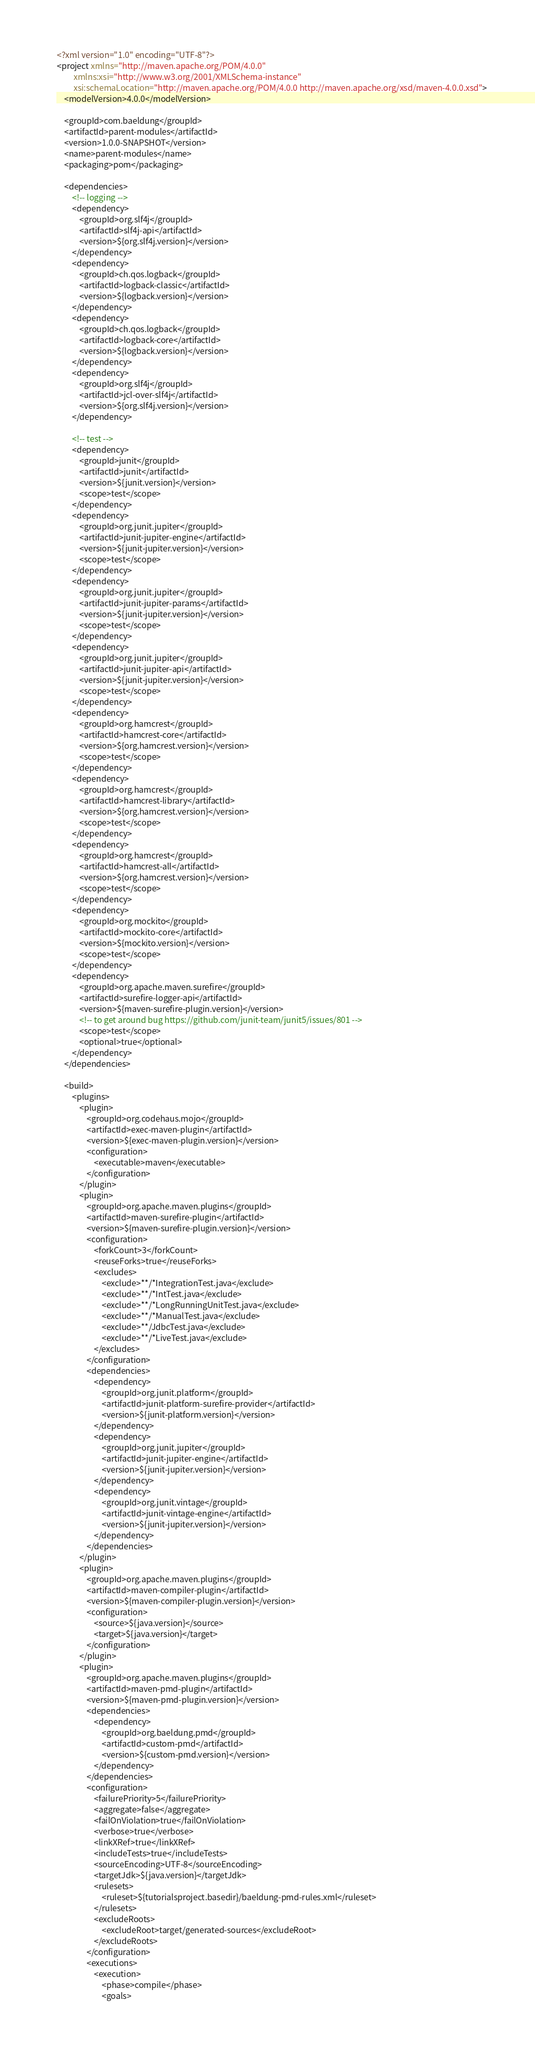Convert code to text. <code><loc_0><loc_0><loc_500><loc_500><_XML_><?xml version="1.0" encoding="UTF-8"?>
<project xmlns="http://maven.apache.org/POM/4.0.0"
		 xmlns:xsi="http://www.w3.org/2001/XMLSchema-instance"
		 xsi:schemaLocation="http://maven.apache.org/POM/4.0.0 http://maven.apache.org/xsd/maven-4.0.0.xsd">
	<modelVersion>4.0.0</modelVersion>

	<groupId>com.baeldung</groupId>
	<artifactId>parent-modules</artifactId>
	<version>1.0.0-SNAPSHOT</version>
	<name>parent-modules</name>
	<packaging>pom</packaging>

	<dependencies>
		<!-- logging -->
		<dependency>
			<groupId>org.slf4j</groupId>
			<artifactId>slf4j-api</artifactId>
			<version>${org.slf4j.version}</version>
		</dependency>
		<dependency>
			<groupId>ch.qos.logback</groupId>
			<artifactId>logback-classic</artifactId>
			<version>${logback.version}</version>
		</dependency>
		<dependency>
			<groupId>ch.qos.logback</groupId>
			<artifactId>logback-core</artifactId>
			<version>${logback.version}</version>
		</dependency>
		<dependency>
			<groupId>org.slf4j</groupId>
			<artifactId>jcl-over-slf4j</artifactId>
			<version>${org.slf4j.version}</version>
		</dependency>

		<!-- test -->
		<dependency>
			<groupId>junit</groupId>
			<artifactId>junit</artifactId>
			<version>${junit.version}</version>
			<scope>test</scope>
		</dependency>
		<dependency>
			<groupId>org.junit.jupiter</groupId>
			<artifactId>junit-jupiter-engine</artifactId>
			<version>${junit-jupiter.version}</version>
			<scope>test</scope>
		</dependency>
		<dependency>
			<groupId>org.junit.jupiter</groupId>
			<artifactId>junit-jupiter-params</artifactId>
			<version>${junit-jupiter.version}</version>
			<scope>test</scope>
		</dependency>
		<dependency>
			<groupId>org.junit.jupiter</groupId>
			<artifactId>junit-jupiter-api</artifactId>
			<version>${junit-jupiter.version}</version>
			<scope>test</scope>
		</dependency>
		<dependency>
			<groupId>org.hamcrest</groupId>
			<artifactId>hamcrest-core</artifactId>
			<version>${org.hamcrest.version}</version>
			<scope>test</scope>
		</dependency>
		<dependency>
			<groupId>org.hamcrest</groupId>
			<artifactId>hamcrest-library</artifactId>
			<version>${org.hamcrest.version}</version>
			<scope>test</scope>
		</dependency>
		<dependency>
			<groupId>org.hamcrest</groupId>
			<artifactId>hamcrest-all</artifactId>
			<version>${org.hamcrest.version}</version>
			<scope>test</scope>
		</dependency>
		<dependency>
			<groupId>org.mockito</groupId>
			<artifactId>mockito-core</artifactId>
			<version>${mockito.version}</version>
			<scope>test</scope>
		</dependency>
		<dependency>
			<groupId>org.apache.maven.surefire</groupId>
			<artifactId>surefire-logger-api</artifactId>
			<version>${maven-surefire-plugin.version}</version>
			<!-- to get around bug https://github.com/junit-team/junit5/issues/801 -->
			<scope>test</scope>
			<optional>true</optional>
		</dependency>
	</dependencies>

	<build>
		<plugins>
			<plugin>
				<groupId>org.codehaus.mojo</groupId>
				<artifactId>exec-maven-plugin</artifactId>
				<version>${exec-maven-plugin.version}</version>
				<configuration>
					<executable>maven</executable>
				</configuration>
			</plugin>
			<plugin>
				<groupId>org.apache.maven.plugins</groupId>
				<artifactId>maven-surefire-plugin</artifactId>
				<version>${maven-surefire-plugin.version}</version>
				<configuration>
					<forkCount>3</forkCount>
					<reuseForks>true</reuseForks>
					<excludes>
						<exclude>**/*IntegrationTest.java</exclude>
						<exclude>**/*IntTest.java</exclude>
						<exclude>**/*LongRunningUnitTest.java</exclude>
						<exclude>**/*ManualTest.java</exclude>
						<exclude>**/JdbcTest.java</exclude>
						<exclude>**/*LiveTest.java</exclude>
					</excludes>
				</configuration>
				<dependencies>
					<dependency>
						<groupId>org.junit.platform</groupId>
						<artifactId>junit-platform-surefire-provider</artifactId>
						<version>${junit-platform.version}</version>
					</dependency>
					<dependency>
						<groupId>org.junit.jupiter</groupId>
						<artifactId>junit-jupiter-engine</artifactId>
						<version>${junit-jupiter.version}</version>
					</dependency>
					<dependency>
						<groupId>org.junit.vintage</groupId>
						<artifactId>junit-vintage-engine</artifactId>
						<version>${junit-jupiter.version}</version>
					</dependency>
				</dependencies>
			</plugin>
			<plugin>
				<groupId>org.apache.maven.plugins</groupId>
				<artifactId>maven-compiler-plugin</artifactId>
				<version>${maven-compiler-plugin.version}</version>
				<configuration>
					<source>${java.version}</source>
					<target>${java.version}</target>
				</configuration>
			</plugin>
			<plugin>
				<groupId>org.apache.maven.plugins</groupId>
				<artifactId>maven-pmd-plugin</artifactId>
				<version>${maven-pmd-plugin.version}</version>
				<dependencies>
					<dependency>
						<groupId>org.baeldung.pmd</groupId>
						<artifactId>custom-pmd</artifactId>
						<version>${custom-pmd.version}</version>
					</dependency>
				</dependencies>
				<configuration>
					<failurePriority>5</failurePriority>
					<aggregate>false</aggregate>
					<failOnViolation>true</failOnViolation>
					<verbose>true</verbose>
					<linkXRef>true</linkXRef>
					<includeTests>true</includeTests>
					<sourceEncoding>UTF-8</sourceEncoding>
					<targetJdk>${java.version}</targetJdk>
					<rulesets>
						<ruleset>${tutorialsproject.basedir}/baeldung-pmd-rules.xml</ruleset>
					</rulesets>
					<excludeRoots>
						<excludeRoot>target/generated-sources</excludeRoot>
					</excludeRoots>
				</configuration>
				<executions>
					<execution>
						<phase>compile</phase>
						<goals></code> 